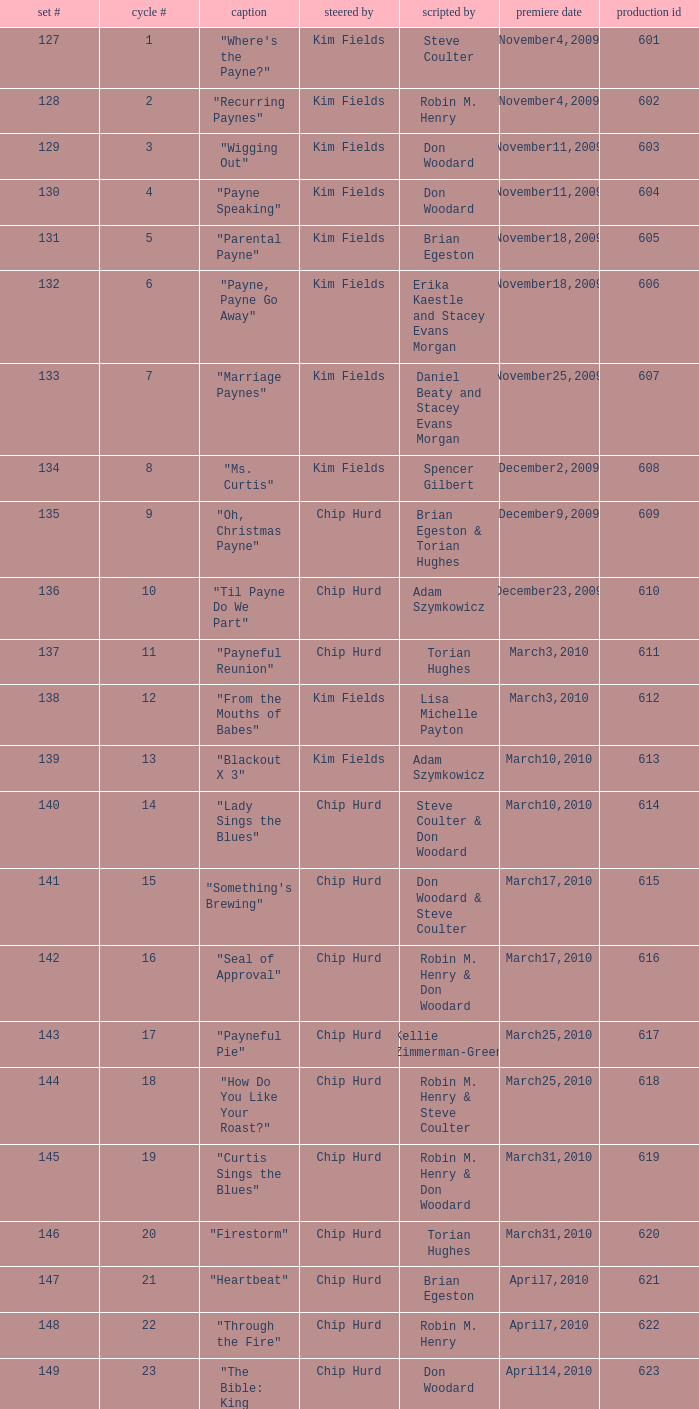What is the original air dates for the title "firestorm"? March31,2010. 